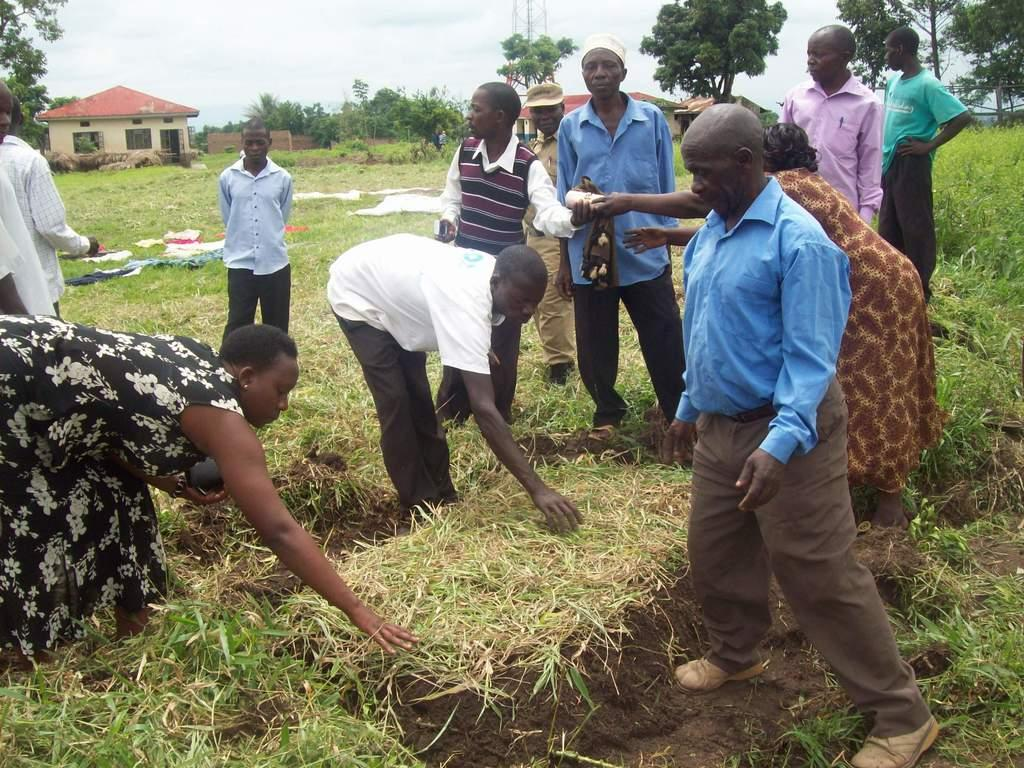Who or what can be seen in the image? There are people in the image. What type of surface is at the bottom of the image? There is grass at the bottom of the image. What items are visible that people might wear? Clothes are visible in the image. What type of structures can be seen in the background of the image? There are sheds in the background of the image. What natural elements are present in the background of the image? Trees and the sky are visible in the background of the image. How many pigs are running around in the image? There are no pigs present in the image. What type of underground room can be seen in the image? There is no cellar present in the image. 